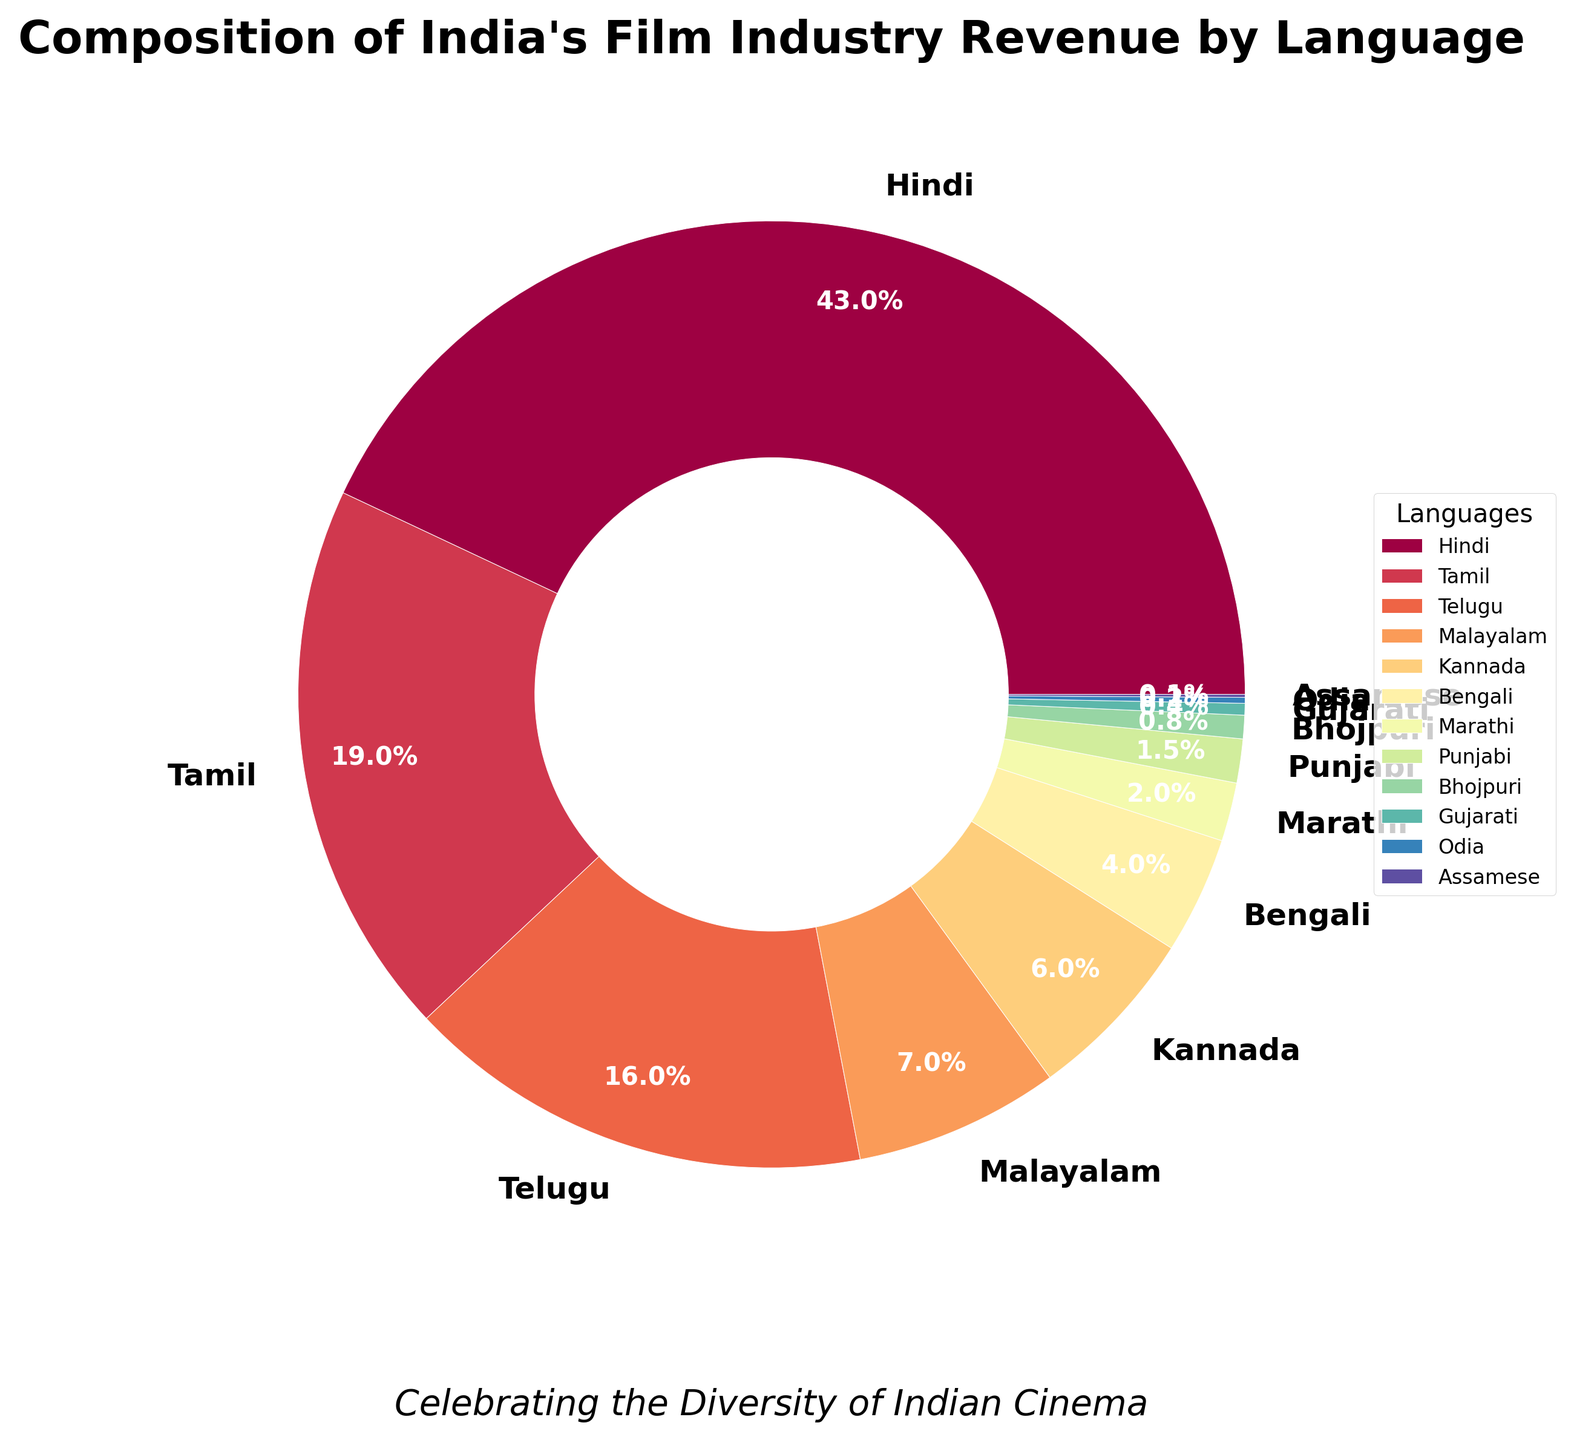Which language contributes the most to India's film industry revenue according to the pie chart? The pie chart shows the relative percentage of revenue contributed by each language. Hindi occupies the largest section, indicating it contributes the most.
Answer: Hindi What is the total percentage revenue contribution from Tamil and Telugu films? To find the total percentage for Tamil and Telugu, add their individual percentages: Tamil (19%) + Telugu (16%) = 35%.
Answer: 35% Which language contributes more to the revenue: Kannada or Bengali? By comparing their sections in the pie chart, Kannada contributes 6% while Bengali contributes 4%. Hence, Kannada contributes more.
Answer: Kannada How much more does Hindi contribute compared to Malayalam? To determine the difference, subtract Malayalam's percentage from Hindi's: 43% - 7% = 36%. Hindi contributes 36% more than Malayalam.
Answer: 36% Identify the languages that together contribute less than 5% to the revenue. Looking at the sections corresponding to revenues less than 5%, the languages are Marathi (2%), Punjabi (1.5%), Bhojpuri (0.8%), Gujarati (0.4%), Odia (0.2%), and Assamese (0.1%).
Answer: Marathi, Punjabi, Bhojpuri, Gujarati, Odia, Assamese If you group Tamil, Telugu, and Malayalam films together, do they contribute more or less than Hindi films alone? Summing up the percentages for Tamil (19%), Telugu (16%), and Malayalam (7%), we get 19% + 16% + 7% = 42%. Comparatively, Hindi alone is 43%. Therefore, they contribute slightly less than Hindi films alone.
Answer: Less What proportion of the revenue is contributed by the top three languages combined? The top three languages by revenue are Hindi (43%), Tamil (19%), and Telugu (16%). Their combined contribution is 43% + 19% + 16% = 78%.
Answer: 78% Which language has the smallest contribution, and what is its percentage? The pie chart shows Assamese with the smallest section, contributing 0.1% to the revenue.
Answer: Assamese, 0.1% 